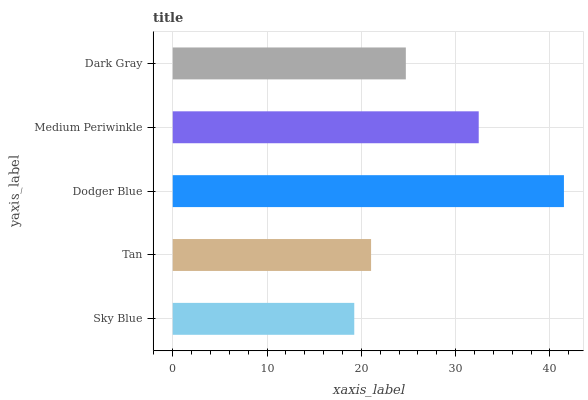Is Sky Blue the minimum?
Answer yes or no. Yes. Is Dodger Blue the maximum?
Answer yes or no. Yes. Is Tan the minimum?
Answer yes or no. No. Is Tan the maximum?
Answer yes or no. No. Is Tan greater than Sky Blue?
Answer yes or no. Yes. Is Sky Blue less than Tan?
Answer yes or no. Yes. Is Sky Blue greater than Tan?
Answer yes or no. No. Is Tan less than Sky Blue?
Answer yes or no. No. Is Dark Gray the high median?
Answer yes or no. Yes. Is Dark Gray the low median?
Answer yes or no. Yes. Is Sky Blue the high median?
Answer yes or no. No. Is Tan the low median?
Answer yes or no. No. 